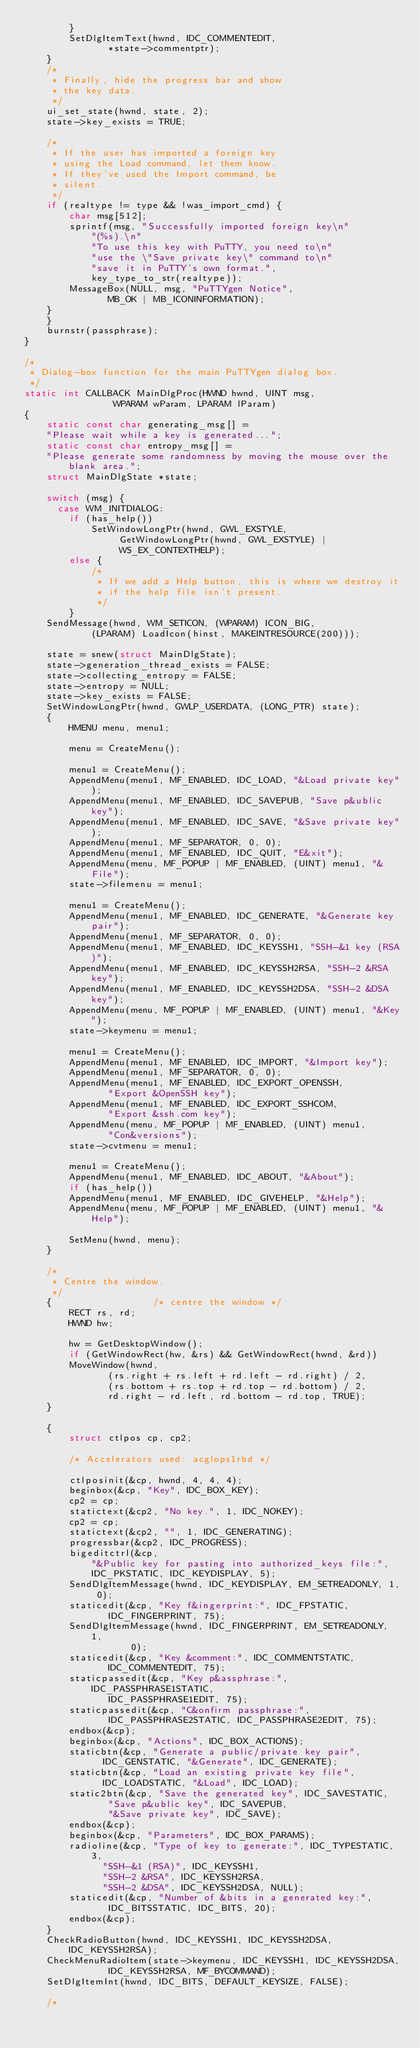Convert code to text. <code><loc_0><loc_0><loc_500><loc_500><_C_>	    }
	    SetDlgItemText(hwnd, IDC_COMMENTEDIT,
			   *state->commentptr);
	}
	/*
	 * Finally, hide the progress bar and show
	 * the key data.
	 */
	ui_set_state(hwnd, state, 2);
	state->key_exists = TRUE;

	/*
	 * If the user has imported a foreign key
	 * using the Load command, let them know.
	 * If they've used the Import command, be
	 * silent.
	 */
	if (realtype != type && !was_import_cmd) {
	    char msg[512];
	    sprintf(msg, "Successfully imported foreign key\n"
		    "(%s).\n"
		    "To use this key with PuTTY, you need to\n"
		    "use the \"Save private key\" command to\n"
		    "save it in PuTTY's own format.",
		    key_type_to_str(realtype));
	    MessageBox(NULL, msg, "PuTTYgen Notice",
		       MB_OK | MB_ICONINFORMATION);
	}
    }
    burnstr(passphrase);
}

/*
 * Dialog-box function for the main PuTTYgen dialog box.
 */
static int CALLBACK MainDlgProc(HWND hwnd, UINT msg,
				WPARAM wParam, LPARAM lParam)
{
    static const char generating_msg[] =
	"Please wait while a key is generated...";
    static const char entropy_msg[] =
	"Please generate some randomness by moving the mouse over the blank area.";
    struct MainDlgState *state;

    switch (msg) {
      case WM_INITDIALOG:
        if (has_help())
            SetWindowLongPtr(hwnd, GWL_EXSTYLE,
			     GetWindowLongPtr(hwnd, GWL_EXSTYLE) |
			     WS_EX_CONTEXTHELP);
        else {
            /*
             * If we add a Help button, this is where we destroy it
             * if the help file isn't present.
             */
        }
	SendMessage(hwnd, WM_SETICON, (WPARAM) ICON_BIG,
		    (LPARAM) LoadIcon(hinst, MAKEINTRESOURCE(200)));

	state = snew(struct MainDlgState);
	state->generation_thread_exists = FALSE;
	state->collecting_entropy = FALSE;
	state->entropy = NULL;
	state->key_exists = FALSE;
	SetWindowLongPtr(hwnd, GWLP_USERDATA, (LONG_PTR) state);
	{
	    HMENU menu, menu1;

	    menu = CreateMenu();

	    menu1 = CreateMenu();
	    AppendMenu(menu1, MF_ENABLED, IDC_LOAD, "&Load private key");
	    AppendMenu(menu1, MF_ENABLED, IDC_SAVEPUB, "Save p&ublic key");
	    AppendMenu(menu1, MF_ENABLED, IDC_SAVE, "&Save private key");
	    AppendMenu(menu1, MF_SEPARATOR, 0, 0);
	    AppendMenu(menu1, MF_ENABLED, IDC_QUIT, "E&xit");
	    AppendMenu(menu, MF_POPUP | MF_ENABLED, (UINT) menu1, "&File");
	    state->filemenu = menu1;

	    menu1 = CreateMenu();
	    AppendMenu(menu1, MF_ENABLED, IDC_GENERATE, "&Generate key pair");
	    AppendMenu(menu1, MF_SEPARATOR, 0, 0);
	    AppendMenu(menu1, MF_ENABLED, IDC_KEYSSH1, "SSH-&1 key (RSA)");
	    AppendMenu(menu1, MF_ENABLED, IDC_KEYSSH2RSA, "SSH-2 &RSA key");
	    AppendMenu(menu1, MF_ENABLED, IDC_KEYSSH2DSA, "SSH-2 &DSA key");
	    AppendMenu(menu, MF_POPUP | MF_ENABLED, (UINT) menu1, "&Key");
	    state->keymenu = menu1;

	    menu1 = CreateMenu();
	    AppendMenu(menu1, MF_ENABLED, IDC_IMPORT, "&Import key");
	    AppendMenu(menu1, MF_SEPARATOR, 0, 0);
	    AppendMenu(menu1, MF_ENABLED, IDC_EXPORT_OPENSSH,
		       "Export &OpenSSH key");
	    AppendMenu(menu1, MF_ENABLED, IDC_EXPORT_SSHCOM,
		       "Export &ssh.com key");
	    AppendMenu(menu, MF_POPUP | MF_ENABLED, (UINT) menu1,
		       "Con&versions");
	    state->cvtmenu = menu1;

	    menu1 = CreateMenu();
	    AppendMenu(menu1, MF_ENABLED, IDC_ABOUT, "&About");
	    if (has_help())
		AppendMenu(menu1, MF_ENABLED, IDC_GIVEHELP, "&Help");
	    AppendMenu(menu, MF_POPUP | MF_ENABLED, (UINT) menu1, "&Help");

	    SetMenu(hwnd, menu);
	}

	/*
	 * Centre the window.
	 */
	{			       /* centre the window */
	    RECT rs, rd;
	    HWND hw;

	    hw = GetDesktopWindow();
	    if (GetWindowRect(hw, &rs) && GetWindowRect(hwnd, &rd))
		MoveWindow(hwnd,
			   (rs.right + rs.left + rd.left - rd.right) / 2,
			   (rs.bottom + rs.top + rd.top - rd.bottom) / 2,
			   rd.right - rd.left, rd.bottom - rd.top, TRUE);
	}

	{
	    struct ctlpos cp, cp2;

	    /* Accelerators used: acglops1rbd */

	    ctlposinit(&cp, hwnd, 4, 4, 4);
	    beginbox(&cp, "Key", IDC_BOX_KEY);
	    cp2 = cp;
	    statictext(&cp2, "No key.", 1, IDC_NOKEY);
	    cp2 = cp;
	    statictext(&cp2, "", 1, IDC_GENERATING);
	    progressbar(&cp2, IDC_PROGRESS);
	    bigeditctrl(&cp,
			"&Public key for pasting into authorized_keys file:",
			IDC_PKSTATIC, IDC_KEYDISPLAY, 5);
	    SendDlgItemMessage(hwnd, IDC_KEYDISPLAY, EM_SETREADONLY, 1, 0);
	    staticedit(&cp, "Key f&ingerprint:", IDC_FPSTATIC,
		       IDC_FINGERPRINT, 75);
	    SendDlgItemMessage(hwnd, IDC_FINGERPRINT, EM_SETREADONLY, 1,
			       0);
	    staticedit(&cp, "Key &comment:", IDC_COMMENTSTATIC,
		       IDC_COMMENTEDIT, 75);
	    staticpassedit(&cp, "Key p&assphrase:", IDC_PASSPHRASE1STATIC,
			   IDC_PASSPHRASE1EDIT, 75);
	    staticpassedit(&cp, "C&onfirm passphrase:",
			   IDC_PASSPHRASE2STATIC, IDC_PASSPHRASE2EDIT, 75);
	    endbox(&cp);
	    beginbox(&cp, "Actions", IDC_BOX_ACTIONS);
	    staticbtn(&cp, "Generate a public/private key pair",
		      IDC_GENSTATIC, "&Generate", IDC_GENERATE);
	    staticbtn(&cp, "Load an existing private key file",
		      IDC_LOADSTATIC, "&Load", IDC_LOAD);
	    static2btn(&cp, "Save the generated key", IDC_SAVESTATIC,
		       "Save p&ublic key", IDC_SAVEPUB,
		       "&Save private key", IDC_SAVE);
	    endbox(&cp);
	    beginbox(&cp, "Parameters", IDC_BOX_PARAMS);
	    radioline(&cp, "Type of key to generate:", IDC_TYPESTATIC, 3,
		      "SSH-&1 (RSA)", IDC_KEYSSH1,
		      "SSH-2 &RSA", IDC_KEYSSH2RSA,
		      "SSH-2 &DSA", IDC_KEYSSH2DSA, NULL);
	    staticedit(&cp, "Number of &bits in a generated key:",
		       IDC_BITSSTATIC, IDC_BITS, 20);
	    endbox(&cp);
	}
	CheckRadioButton(hwnd, IDC_KEYSSH1, IDC_KEYSSH2DSA, IDC_KEYSSH2RSA);
	CheckMenuRadioItem(state->keymenu, IDC_KEYSSH1, IDC_KEYSSH2DSA,
			   IDC_KEYSSH2RSA, MF_BYCOMMAND);
	SetDlgItemInt(hwnd, IDC_BITS, DEFAULT_KEYSIZE, FALSE);

	/*</code> 